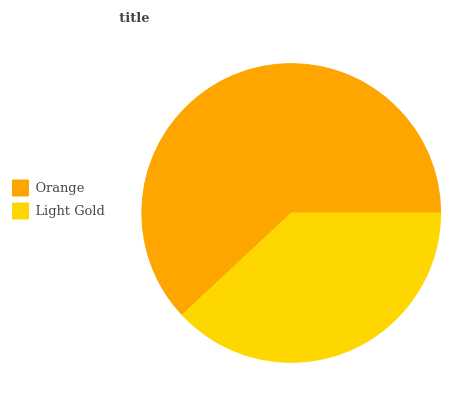Is Light Gold the minimum?
Answer yes or no. Yes. Is Orange the maximum?
Answer yes or no. Yes. Is Light Gold the maximum?
Answer yes or no. No. Is Orange greater than Light Gold?
Answer yes or no. Yes. Is Light Gold less than Orange?
Answer yes or no. Yes. Is Light Gold greater than Orange?
Answer yes or no. No. Is Orange less than Light Gold?
Answer yes or no. No. Is Orange the high median?
Answer yes or no. Yes. Is Light Gold the low median?
Answer yes or no. Yes. Is Light Gold the high median?
Answer yes or no. No. Is Orange the low median?
Answer yes or no. No. 